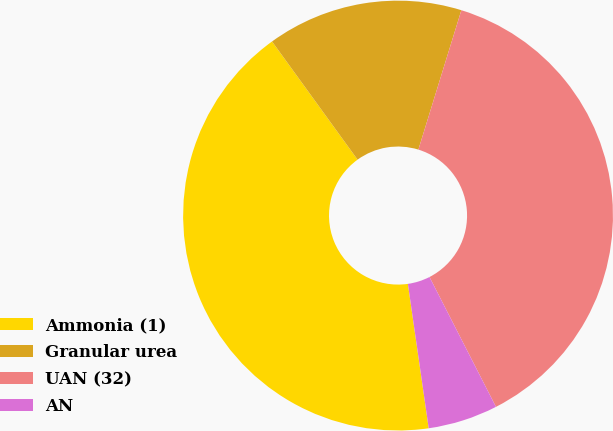<chart> <loc_0><loc_0><loc_500><loc_500><pie_chart><fcel>Ammonia (1)<fcel>Granular urea<fcel>UAN (32)<fcel>AN<nl><fcel>42.31%<fcel>14.73%<fcel>37.71%<fcel>5.25%<nl></chart> 